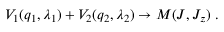<formula> <loc_0><loc_0><loc_500><loc_500>V _ { 1 } ( q _ { 1 } , \lambda _ { 1 } ) + V _ { 2 } ( q _ { 2 } , \lambda _ { 2 } ) \to M ( J , J _ { z } ) \ .</formula> 